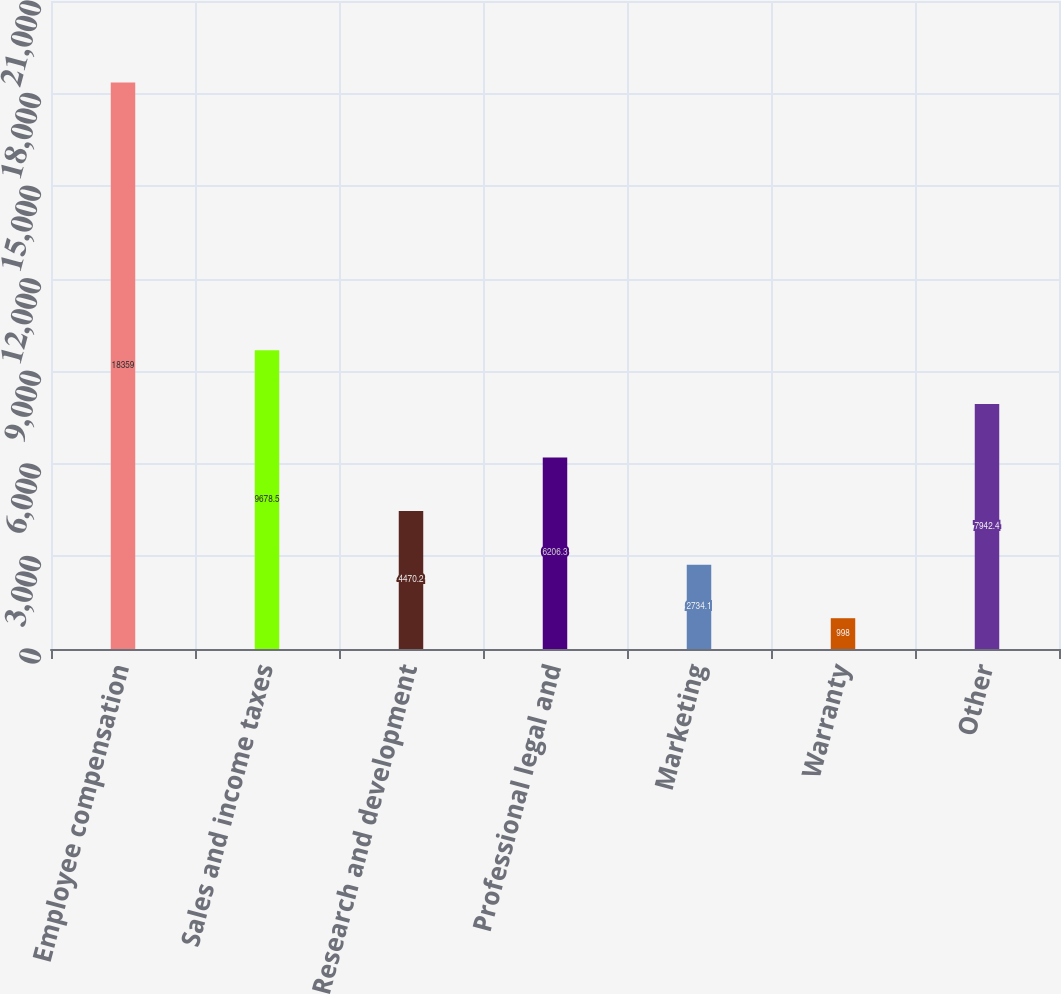Convert chart to OTSL. <chart><loc_0><loc_0><loc_500><loc_500><bar_chart><fcel>Employee compensation<fcel>Sales and income taxes<fcel>Research and development<fcel>Professional legal and<fcel>Marketing<fcel>Warranty<fcel>Other<nl><fcel>18359<fcel>9678.5<fcel>4470.2<fcel>6206.3<fcel>2734.1<fcel>998<fcel>7942.4<nl></chart> 